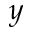<formula> <loc_0><loc_0><loc_500><loc_500>y</formula> 